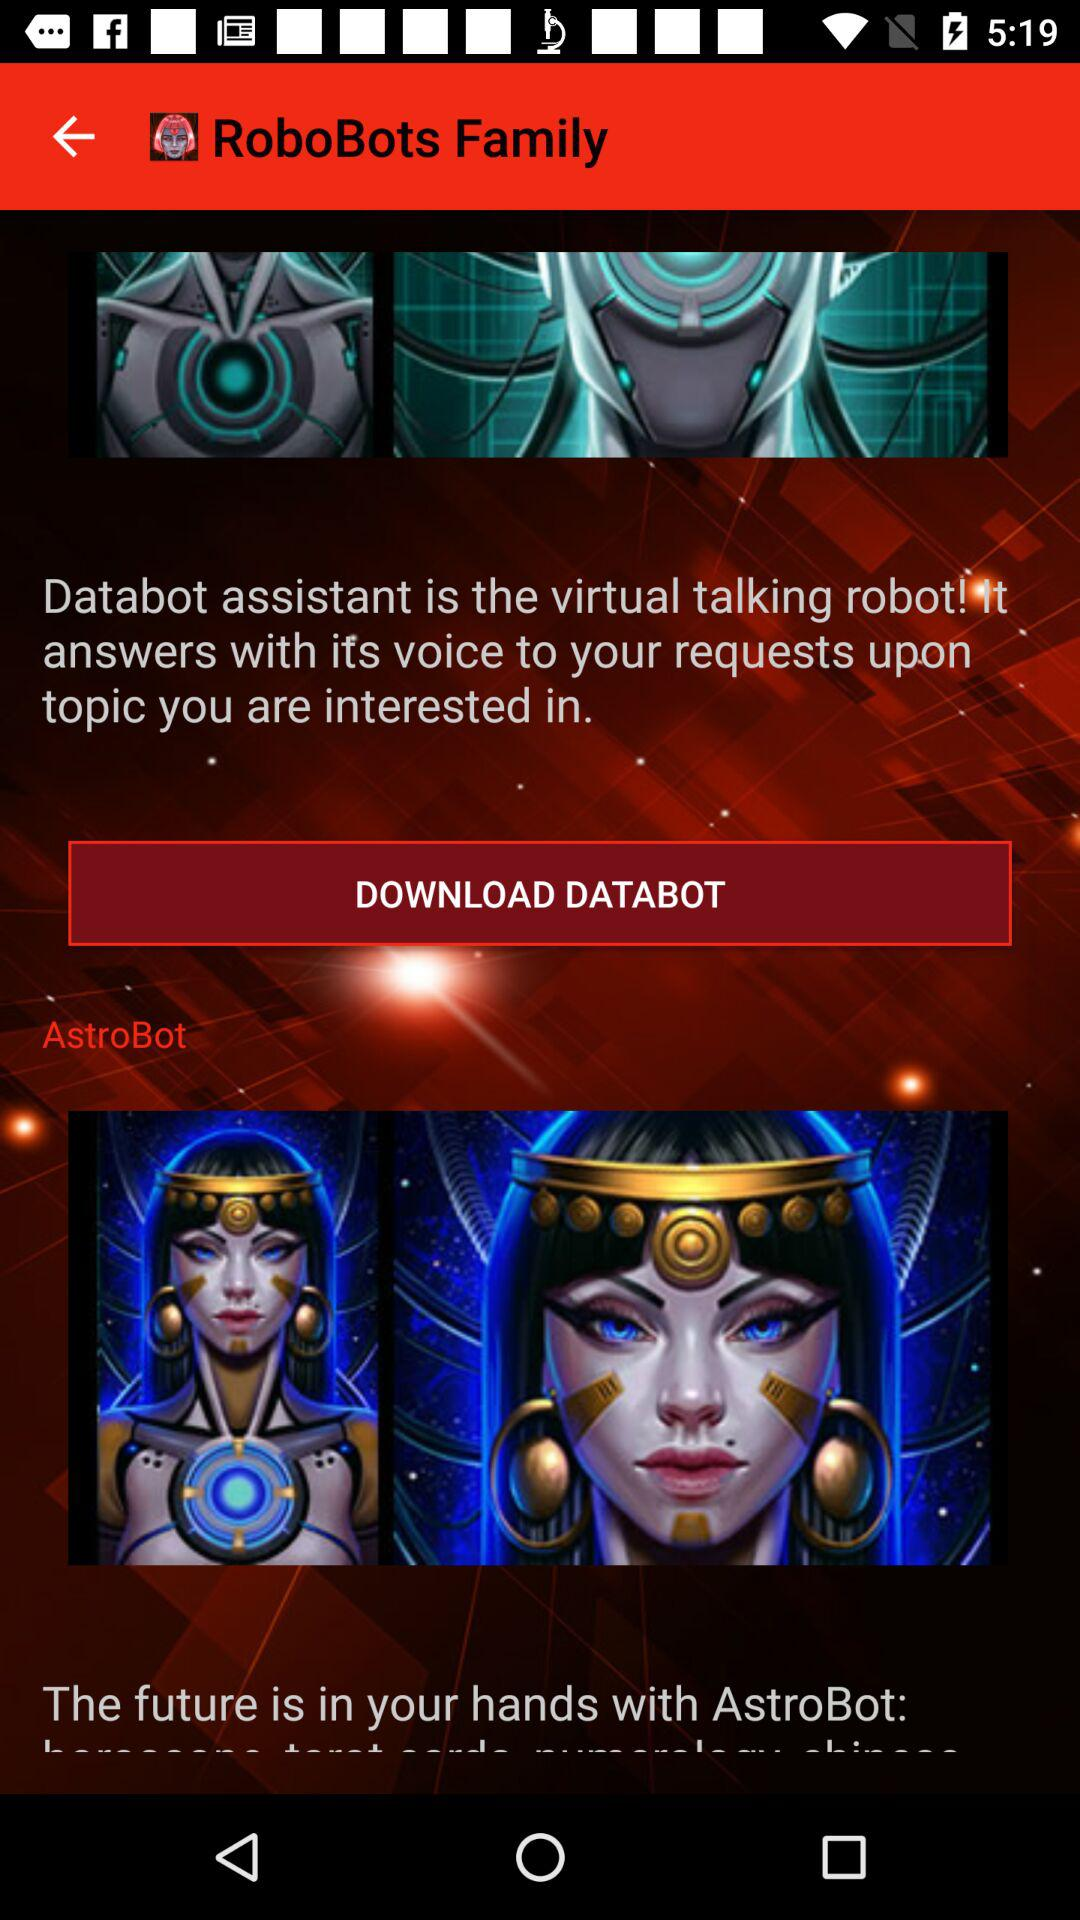Is "DATABOT" downloaded?
When the provided information is insufficient, respond with <no answer>. <no answer> 